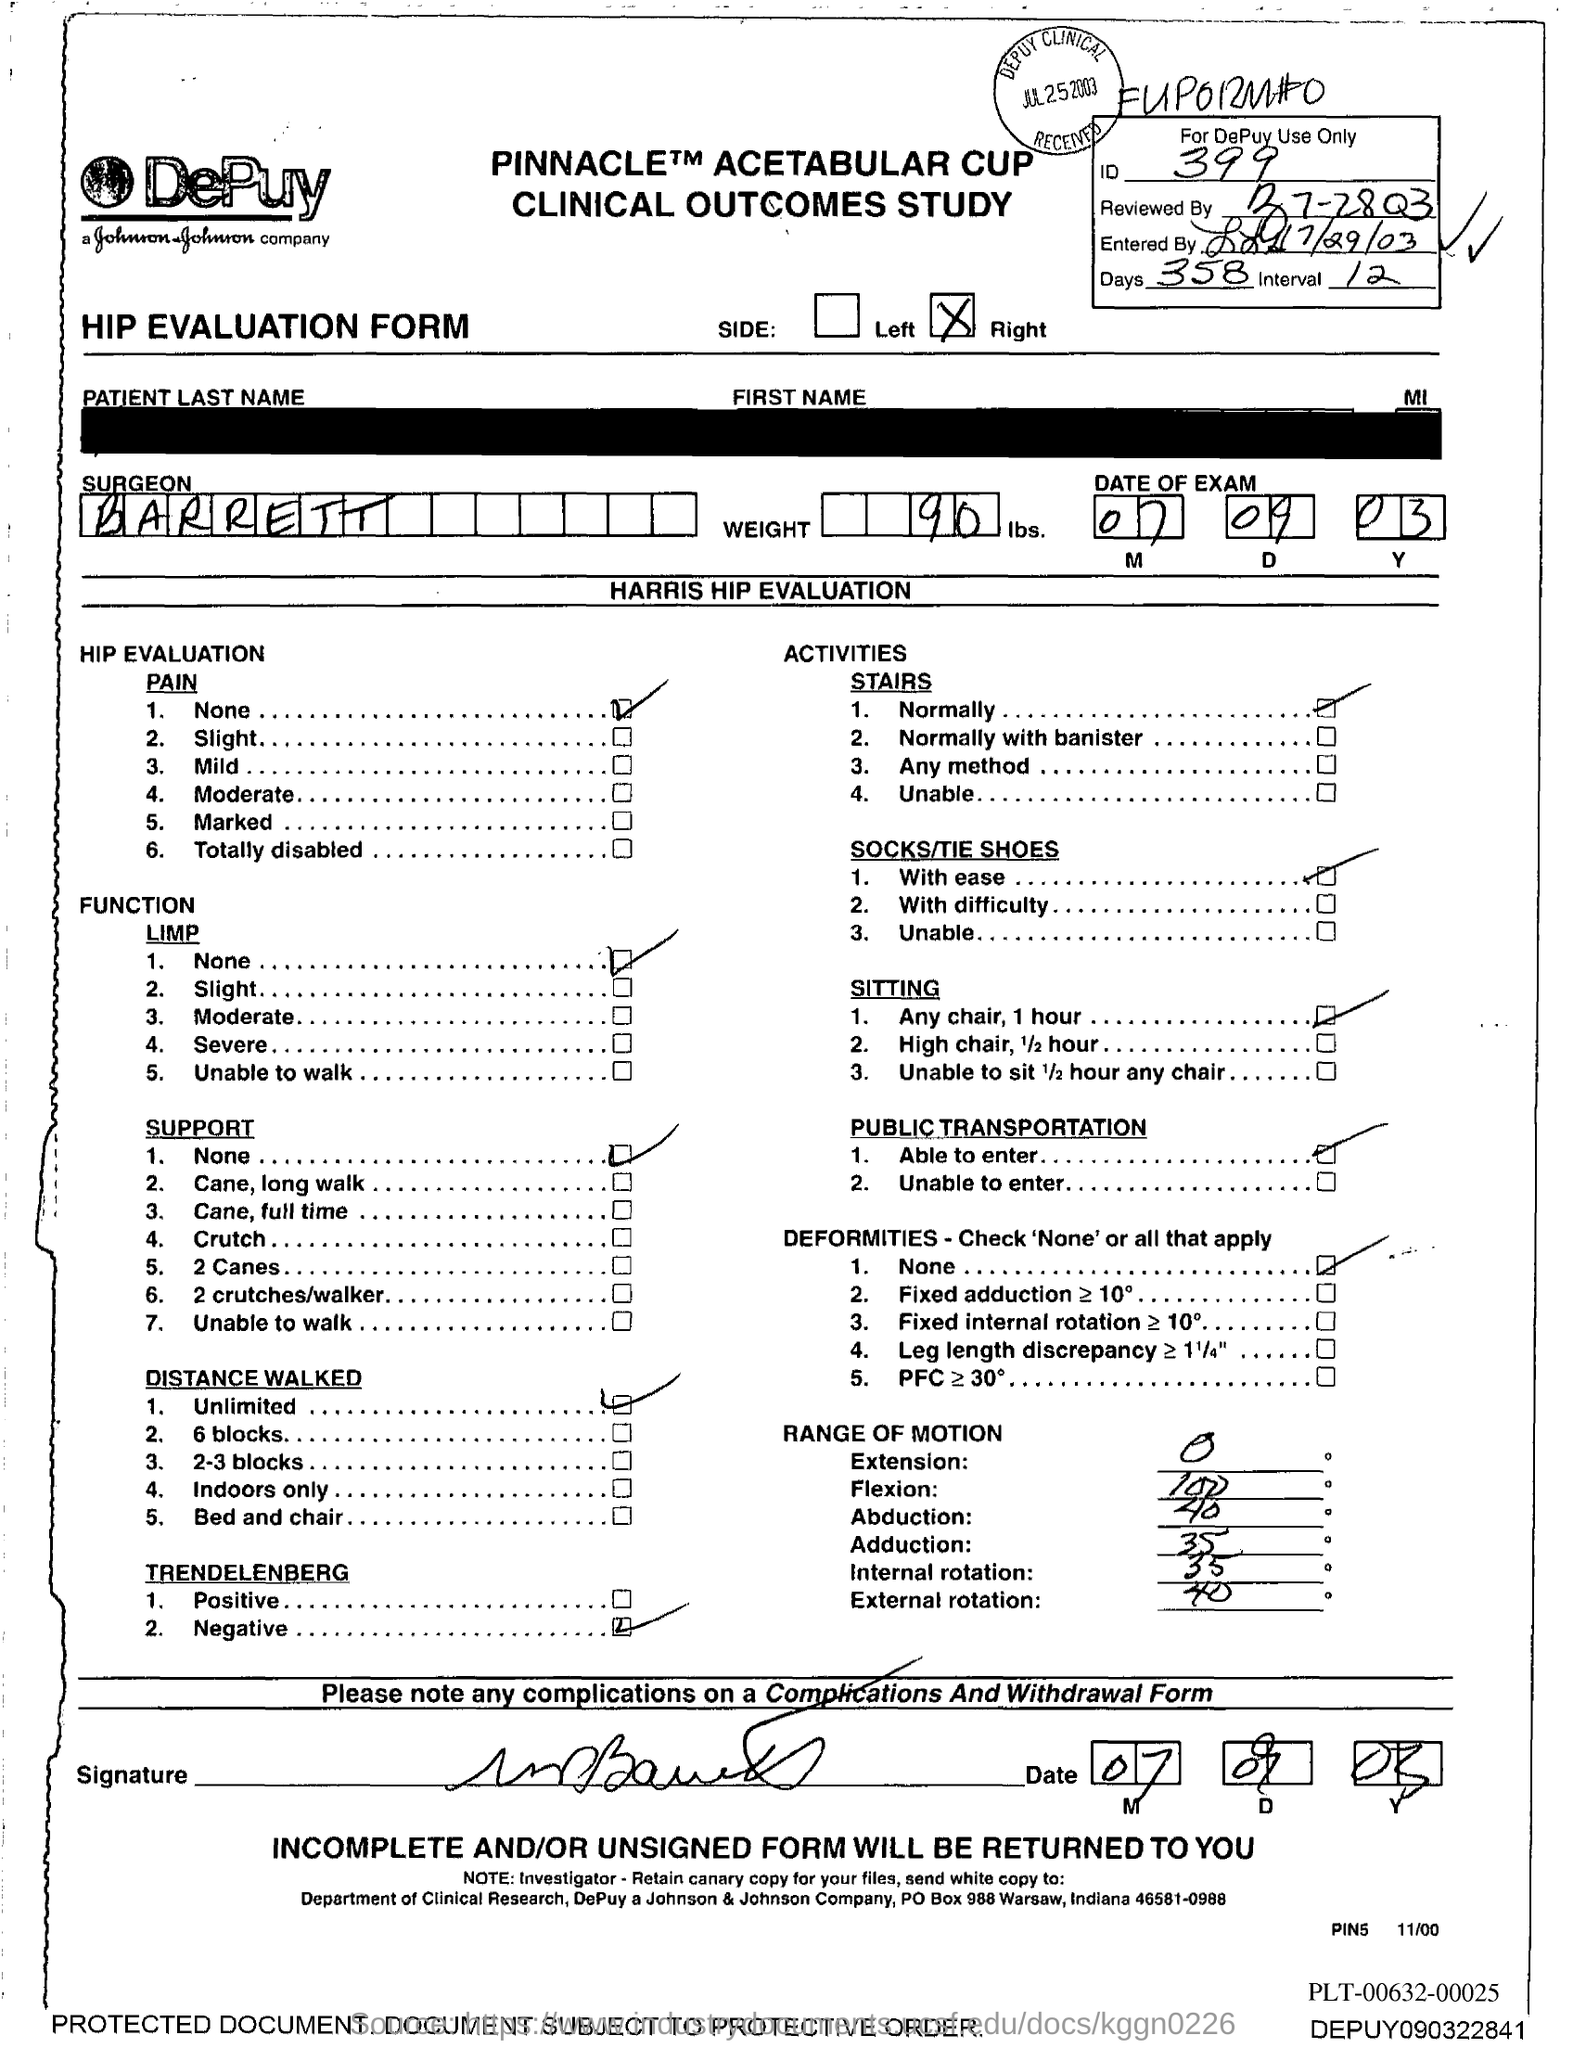What is the ID Number?
Provide a succinct answer. 399. What is the number of days?
Offer a very short reply. 358. What is the name of the Surgeon?
Provide a short and direct response. Barrett. What is the Weight?
Your answer should be compact. 90. 